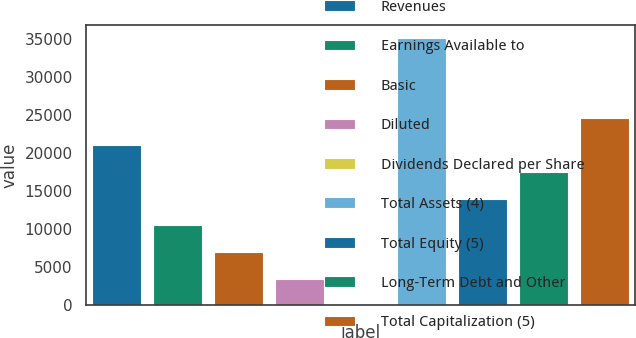Convert chart to OTSL. <chart><loc_0><loc_0><loc_500><loc_500><bar_chart><fcel>Revenues<fcel>Earnings Available to<fcel>Basic<fcel>Diluted<fcel>Dividends Declared per Share<fcel>Total Assets (4)<fcel>Total Equity (5)<fcel>Long-Term Debt and Other<fcel>Total Capitalization (5)<nl><fcel>21033.3<fcel>10517.7<fcel>7012.56<fcel>3507.38<fcel>2.2<fcel>35054<fcel>14022.9<fcel>17528.1<fcel>24538.5<nl></chart> 